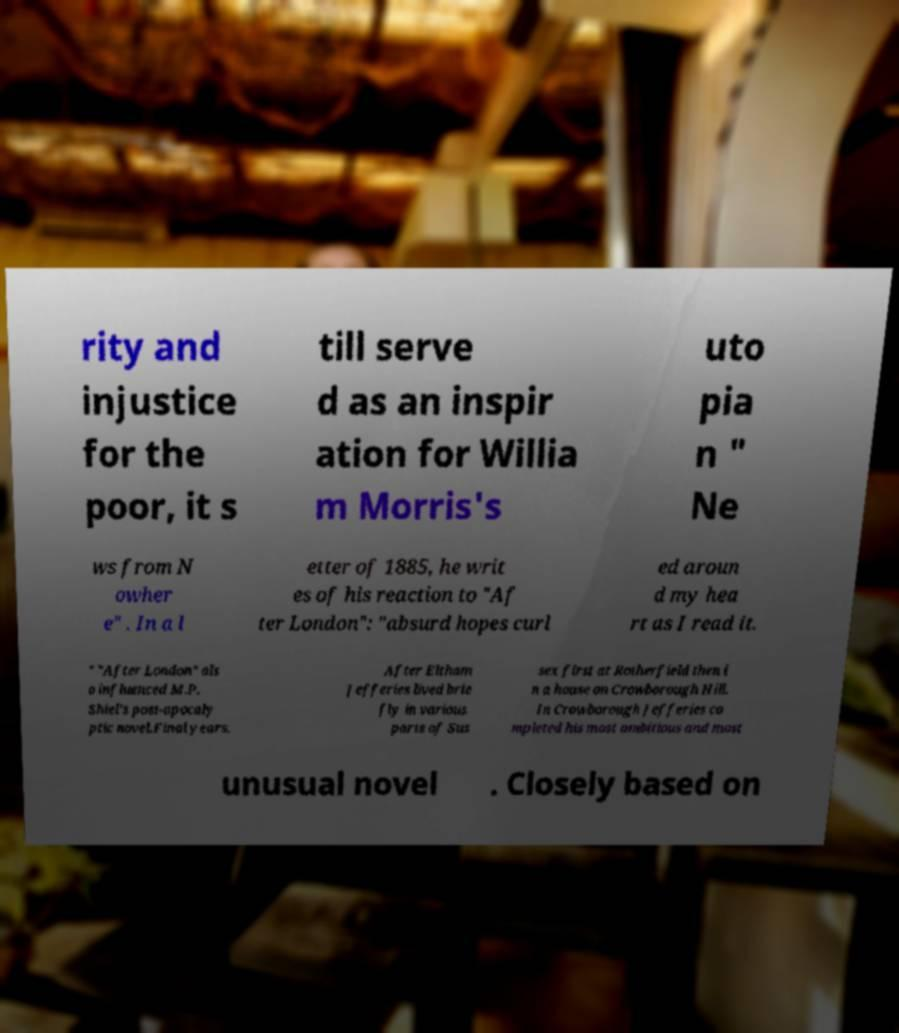Could you assist in decoding the text presented in this image and type it out clearly? rity and injustice for the poor, it s till serve d as an inspir ation for Willia m Morris's uto pia n " Ne ws from N owher e" . In a l etter of 1885, he writ es of his reaction to "Af ter London": "absurd hopes curl ed aroun d my hea rt as I read it. " "After London" als o influenced M.P. Shiel's post-apocaly ptic novel,Final years. After Eltham Jefferies lived brie fly in various parts of Sus sex first at Rotherfield then i n a house on Crowborough Hill. In Crowborough Jefferies co mpleted his most ambitious and most unusual novel . Closely based on 